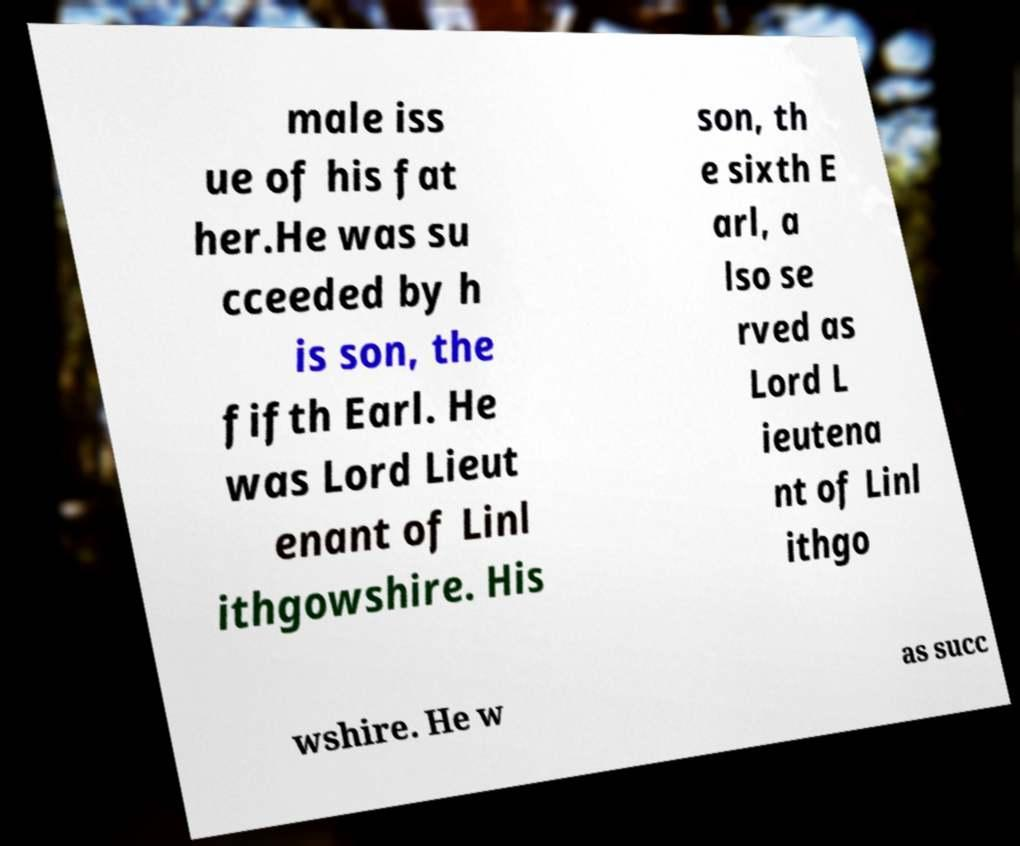I need the written content from this picture converted into text. Can you do that? male iss ue of his fat her.He was su cceeded by h is son, the fifth Earl. He was Lord Lieut enant of Linl ithgowshire. His son, th e sixth E arl, a lso se rved as Lord L ieutena nt of Linl ithgo wshire. He w as succ 